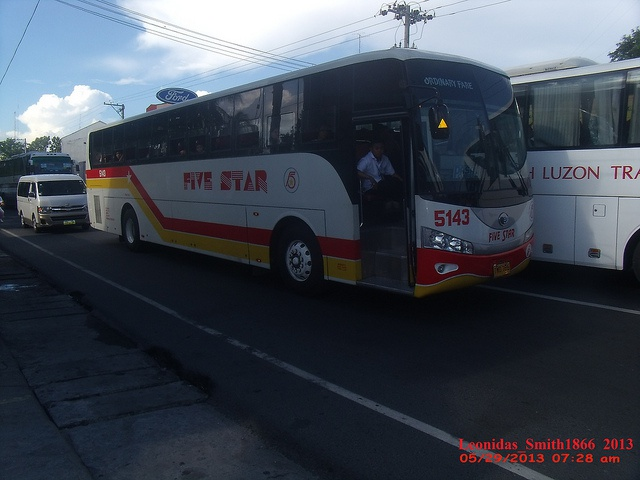Describe the objects in this image and their specific colors. I can see bus in lightblue, black, gray, darkblue, and navy tones, bus in lightblue, gray, darkgray, black, and blue tones, car in lightblue, black, darkgray, and gray tones, bus in lightblue, black, darkblue, blue, and gray tones, and people in lightblue, black, navy, darkblue, and blue tones in this image. 